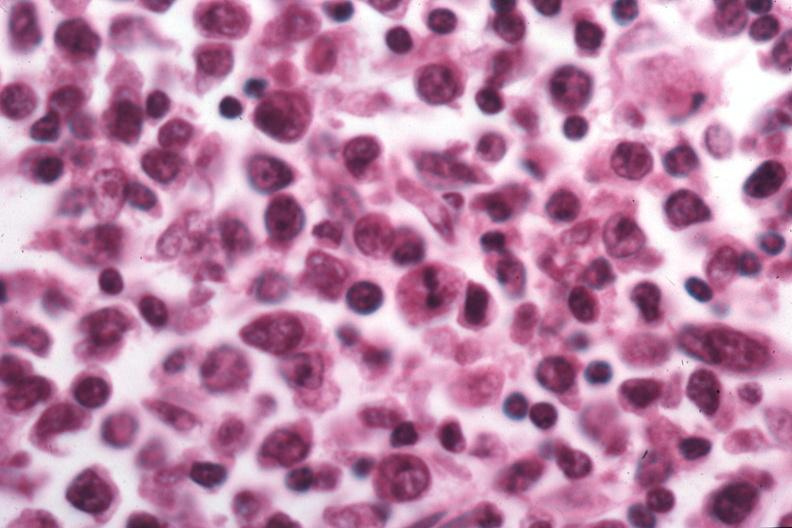does this image show that pleocellular large cell would be best classification?
Answer the question using a single word or phrase. Yes 